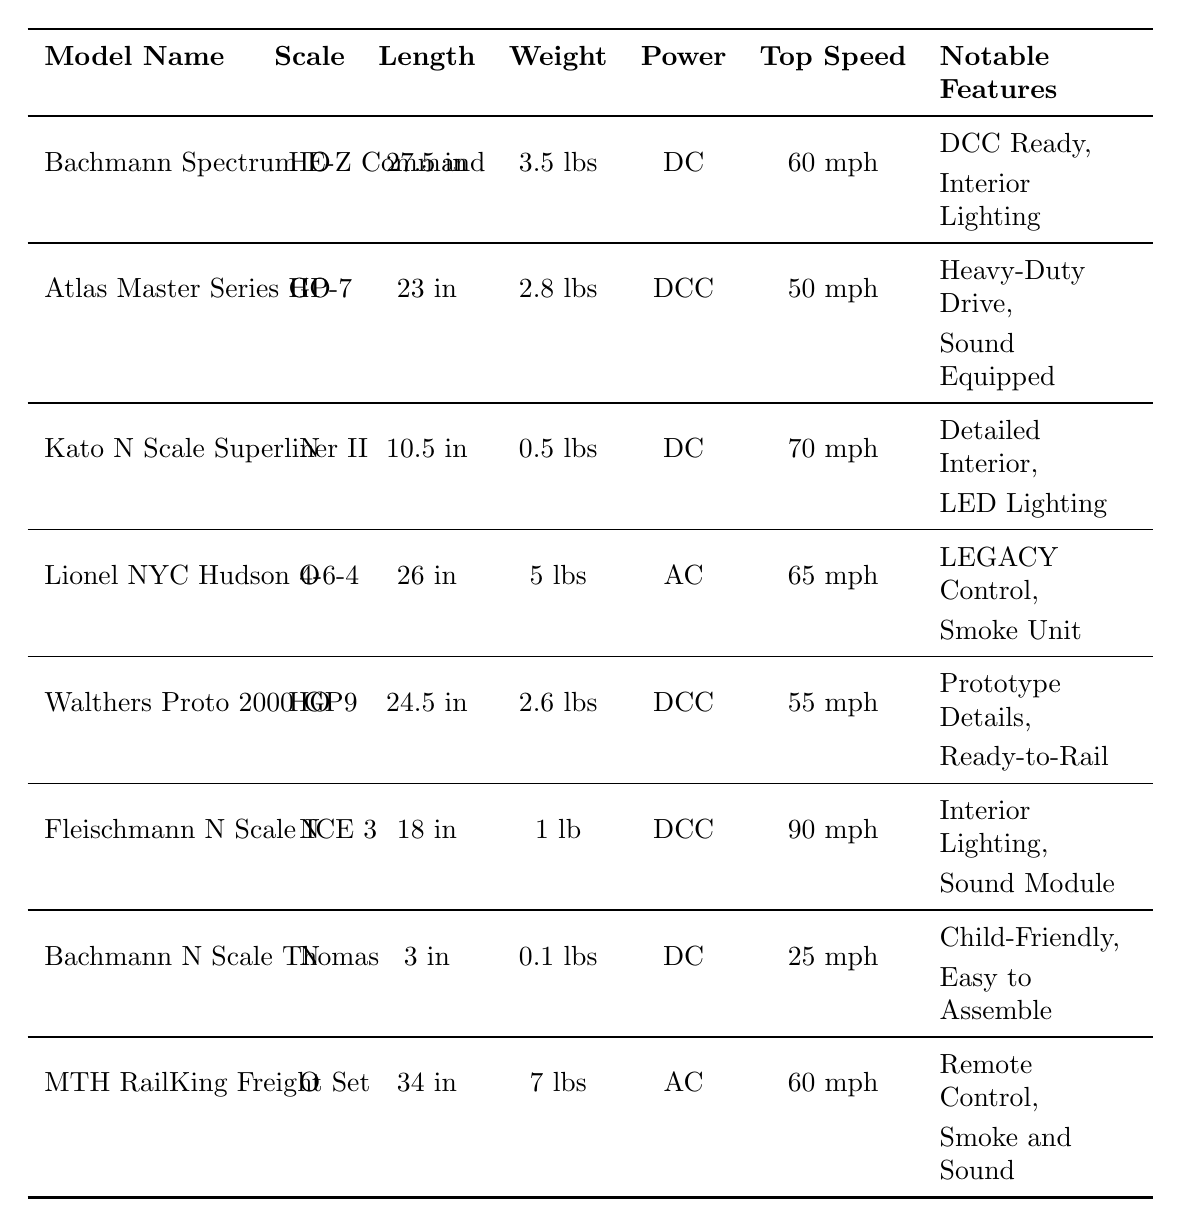What is the length of the Lionel NYC Hudson 4-6-4 model? The table indicates that the length of the Lionel NYC Hudson 4-6-4 model is listed under the "Length" column. It shows "26 inches" as the specific length for this model.
Answer: 26 inches Which model has the highest top speed? By comparing the "Top Speed" values across all models, the highest top speed listed is "90 mph" for the Fleischmann N Scale ICE 3 model.
Answer: Fleischmann N Scale ICE 3 Is the Atlas Master Series GP-7 model DC powered? In the table, the "Power" column for the Atlas Master Series GP-7 indicates "DCC," which means it is not DC powered. Therefore, the answer is no.
Answer: No What is the weight difference between the heaviest and lightest models? The heaviest model is the MTH RailKing Freight Set at "7 lbs," and the lightest is the Bachmann N Scale Thomas and Friends at "0.1 lbs." To find the difference, subtract 0.1 from 7, giving us 6.9 lbs.
Answer: 6.9 lbs How many models have notable features related to lighting? In the "Notable Features" column, we can find references to "Interior Lighting" for three models: Kato N Scale Superliner II, Fleischmann N Scale ICE 3, and Bachmann Spectrum E-Z Command. Therefore, there are three models with lighting features.
Answer: 3 Are all models in the HO scale? The table lists three different scales: HO, N, and O. Models such as Kato N Scale Superliner II and Lionel NYC Hudson 4-6-4 show that not all models are in HO scale.
Answer: No What is the average top speed of the O scale models? The O scale models listed are Lionel NYC Hudson 4-6-4 (65 mph) and MTH RailKing Freight Set (60 mph). To calculate the average, add these speeds together (65 + 60 = 125 mph) and divide by 2, resulting in an average of 62.5 mph.
Answer: 62.5 mph Which model has both sound and smoke features? The MTH RailKing Freight Set explicitly mentions "Smoke and Sound Effects" under "Notable Features," indicating it includes both features.
Answer: MTH RailKing Freight Set What scale is most common among the models listed? The table lists three scales: HO, N, and O. By counting the occurrences, we find five models in HO scale, three in N scale, and two in O scale. Therefore, HO is the most common scale.
Answer: HO Which model would be best suited for children based on notable features? The notable features for Bachmann N Scale Thomas and Friends include "Child-Friendly" and "Easy to Assemble," which makes it particularly suitable for children.
Answer: Bachmann N Scale Thomas and Friends 